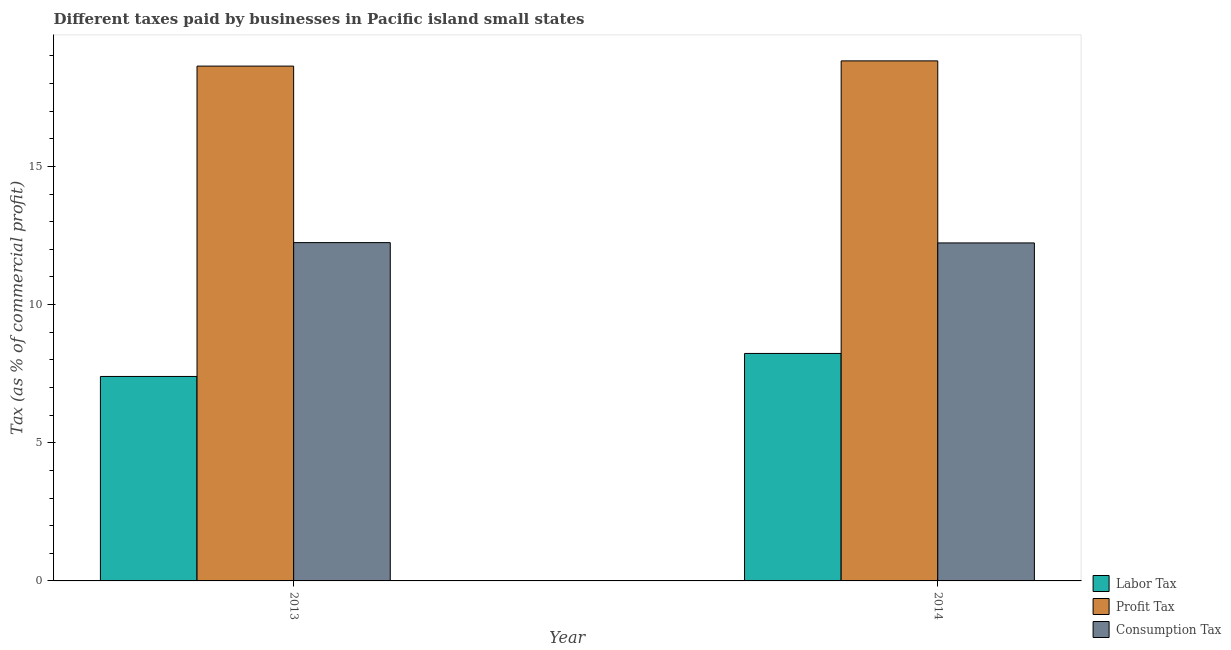How many groups of bars are there?
Make the answer very short. 2. Are the number of bars per tick equal to the number of legend labels?
Offer a very short reply. Yes. Are the number of bars on each tick of the X-axis equal?
Your answer should be compact. Yes. How many bars are there on the 2nd tick from the left?
Provide a succinct answer. 3. What is the percentage of labor tax in 2014?
Ensure brevity in your answer.  8.23. Across all years, what is the maximum percentage of consumption tax?
Offer a terse response. 12.24. Across all years, what is the minimum percentage of consumption tax?
Keep it short and to the point. 12.23. In which year was the percentage of consumption tax maximum?
Make the answer very short. 2013. What is the total percentage of profit tax in the graph?
Keep it short and to the point. 37.46. What is the difference between the percentage of labor tax in 2013 and that in 2014?
Offer a terse response. -0.83. What is the difference between the percentage of consumption tax in 2014 and the percentage of labor tax in 2013?
Offer a terse response. -0.01. What is the average percentage of labor tax per year?
Give a very brief answer. 7.82. In the year 2013, what is the difference between the percentage of labor tax and percentage of profit tax?
Offer a terse response. 0. What is the ratio of the percentage of labor tax in 2013 to that in 2014?
Provide a succinct answer. 0.9. Is the percentage of labor tax in 2013 less than that in 2014?
Your answer should be compact. Yes. In how many years, is the percentage of profit tax greater than the average percentage of profit tax taken over all years?
Give a very brief answer. 1. What does the 3rd bar from the left in 2014 represents?
Your response must be concise. Consumption Tax. What does the 3rd bar from the right in 2013 represents?
Your response must be concise. Labor Tax. Is it the case that in every year, the sum of the percentage of labor tax and percentage of profit tax is greater than the percentage of consumption tax?
Offer a terse response. Yes. How many bars are there?
Make the answer very short. 6. Are all the bars in the graph horizontal?
Your answer should be compact. No. What is the difference between two consecutive major ticks on the Y-axis?
Offer a very short reply. 5. Are the values on the major ticks of Y-axis written in scientific E-notation?
Provide a succinct answer. No. Does the graph contain any zero values?
Offer a very short reply. No. How are the legend labels stacked?
Provide a succinct answer. Vertical. What is the title of the graph?
Keep it short and to the point. Different taxes paid by businesses in Pacific island small states. Does "Capital account" appear as one of the legend labels in the graph?
Offer a terse response. No. What is the label or title of the X-axis?
Provide a succinct answer. Year. What is the label or title of the Y-axis?
Offer a very short reply. Tax (as % of commercial profit). What is the Tax (as % of commercial profit) of Labor Tax in 2013?
Your answer should be compact. 7.4. What is the Tax (as % of commercial profit) of Profit Tax in 2013?
Give a very brief answer. 18.63. What is the Tax (as % of commercial profit) in Consumption Tax in 2013?
Make the answer very short. 12.24. What is the Tax (as % of commercial profit) of Labor Tax in 2014?
Make the answer very short. 8.23. What is the Tax (as % of commercial profit) of Profit Tax in 2014?
Provide a short and direct response. 18.82. What is the Tax (as % of commercial profit) of Consumption Tax in 2014?
Offer a very short reply. 12.23. Across all years, what is the maximum Tax (as % of commercial profit) in Labor Tax?
Your answer should be very brief. 8.23. Across all years, what is the maximum Tax (as % of commercial profit) in Profit Tax?
Provide a succinct answer. 18.82. Across all years, what is the maximum Tax (as % of commercial profit) in Consumption Tax?
Make the answer very short. 12.24. Across all years, what is the minimum Tax (as % of commercial profit) of Profit Tax?
Your answer should be very brief. 18.63. Across all years, what is the minimum Tax (as % of commercial profit) in Consumption Tax?
Keep it short and to the point. 12.23. What is the total Tax (as % of commercial profit) of Labor Tax in the graph?
Your answer should be compact. 15.63. What is the total Tax (as % of commercial profit) in Profit Tax in the graph?
Offer a terse response. 37.46. What is the total Tax (as % of commercial profit) of Consumption Tax in the graph?
Provide a succinct answer. 24.48. What is the difference between the Tax (as % of commercial profit) of Labor Tax in 2013 and that in 2014?
Offer a terse response. -0.83. What is the difference between the Tax (as % of commercial profit) of Profit Tax in 2013 and that in 2014?
Make the answer very short. -0.19. What is the difference between the Tax (as % of commercial profit) of Consumption Tax in 2013 and that in 2014?
Give a very brief answer. 0.01. What is the difference between the Tax (as % of commercial profit) in Labor Tax in 2013 and the Tax (as % of commercial profit) in Profit Tax in 2014?
Offer a very short reply. -11.42. What is the difference between the Tax (as % of commercial profit) in Labor Tax in 2013 and the Tax (as % of commercial profit) in Consumption Tax in 2014?
Make the answer very short. -4.83. What is the difference between the Tax (as % of commercial profit) in Profit Tax in 2013 and the Tax (as % of commercial profit) in Consumption Tax in 2014?
Provide a short and direct response. 6.4. What is the average Tax (as % of commercial profit) in Labor Tax per year?
Give a very brief answer. 7.82. What is the average Tax (as % of commercial profit) of Profit Tax per year?
Your answer should be compact. 18.73. What is the average Tax (as % of commercial profit) of Consumption Tax per year?
Offer a very short reply. 12.24. In the year 2013, what is the difference between the Tax (as % of commercial profit) of Labor Tax and Tax (as % of commercial profit) of Profit Tax?
Provide a succinct answer. -11.23. In the year 2013, what is the difference between the Tax (as % of commercial profit) in Labor Tax and Tax (as % of commercial profit) in Consumption Tax?
Make the answer very short. -4.84. In the year 2013, what is the difference between the Tax (as % of commercial profit) of Profit Tax and Tax (as % of commercial profit) of Consumption Tax?
Provide a short and direct response. 6.39. In the year 2014, what is the difference between the Tax (as % of commercial profit) of Labor Tax and Tax (as % of commercial profit) of Profit Tax?
Your answer should be very brief. -10.59. In the year 2014, what is the difference between the Tax (as % of commercial profit) in Labor Tax and Tax (as % of commercial profit) in Consumption Tax?
Ensure brevity in your answer.  -4. In the year 2014, what is the difference between the Tax (as % of commercial profit) in Profit Tax and Tax (as % of commercial profit) in Consumption Tax?
Your response must be concise. 6.59. What is the ratio of the Tax (as % of commercial profit) of Labor Tax in 2013 to that in 2014?
Offer a very short reply. 0.9. What is the ratio of the Tax (as % of commercial profit) in Consumption Tax in 2013 to that in 2014?
Offer a terse response. 1. What is the difference between the highest and the second highest Tax (as % of commercial profit) of Profit Tax?
Offer a terse response. 0.19. What is the difference between the highest and the second highest Tax (as % of commercial profit) of Consumption Tax?
Give a very brief answer. 0.01. What is the difference between the highest and the lowest Tax (as % of commercial profit) in Profit Tax?
Your answer should be very brief. 0.19. What is the difference between the highest and the lowest Tax (as % of commercial profit) of Consumption Tax?
Offer a terse response. 0.01. 